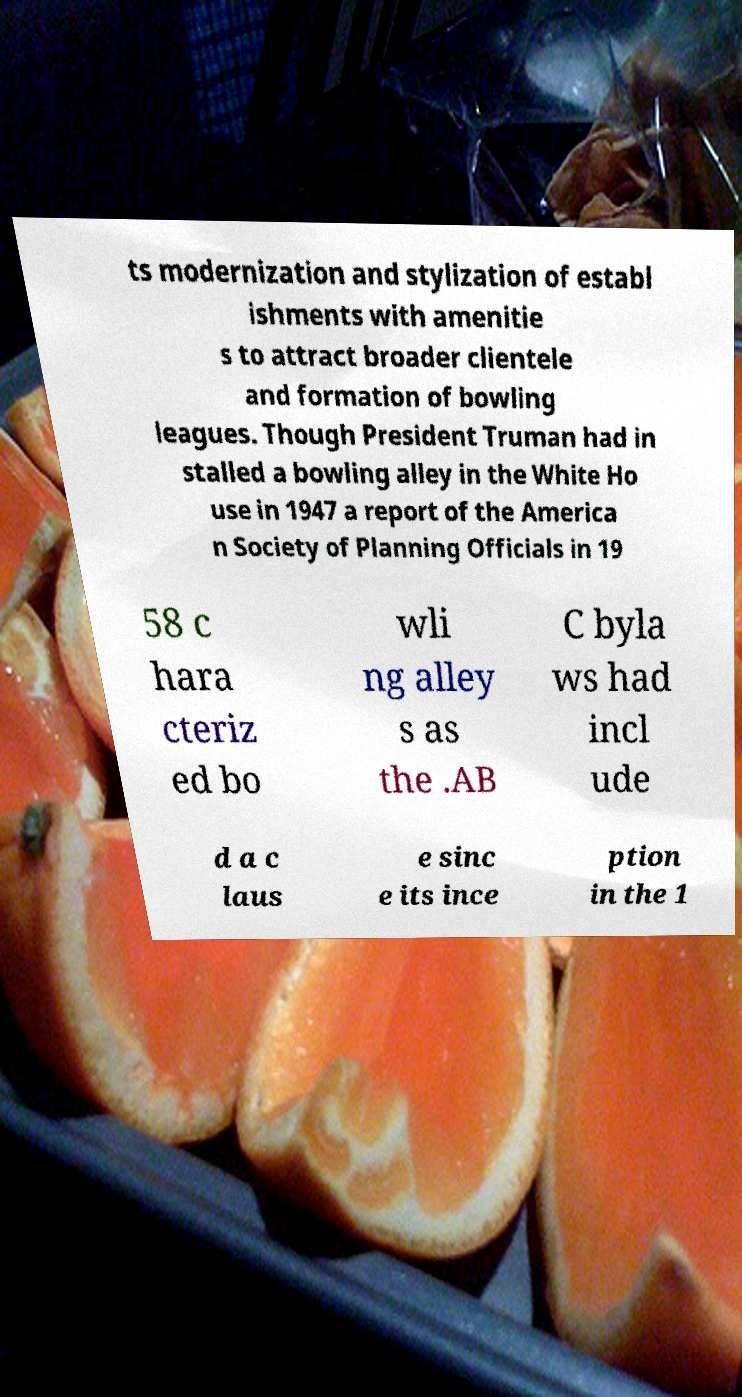For documentation purposes, I need the text within this image transcribed. Could you provide that? ts modernization and stylization of establ ishments with amenitie s to attract broader clientele and formation of bowling leagues. Though President Truman had in stalled a bowling alley in the White Ho use in 1947 a report of the America n Society of Planning Officials in 19 58 c hara cteriz ed bo wli ng alley s as the .AB C byla ws had incl ude d a c laus e sinc e its ince ption in the 1 